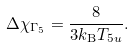<formula> <loc_0><loc_0><loc_500><loc_500>\Delta \chi _ { \Gamma _ { 5 } } = \frac { 8 } { 3 k _ { \text {B} } T _ { 5 u } } .</formula> 